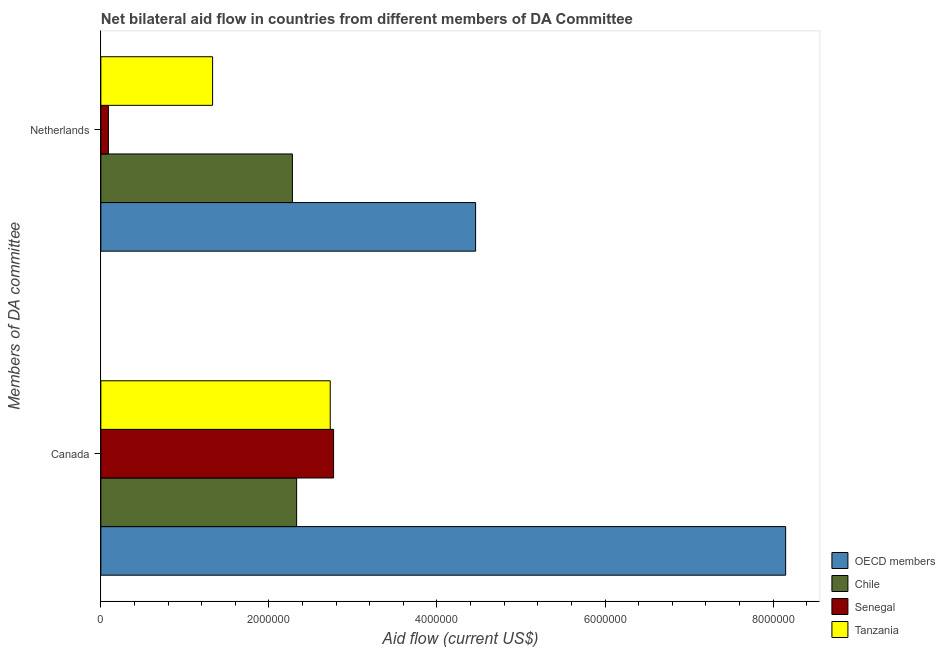How many different coloured bars are there?
Offer a very short reply. 4. How many groups of bars are there?
Offer a very short reply. 2. Are the number of bars on each tick of the Y-axis equal?
Provide a short and direct response. Yes. What is the amount of aid given by canada in OECD members?
Provide a short and direct response. 8.15e+06. Across all countries, what is the maximum amount of aid given by netherlands?
Keep it short and to the point. 4.46e+06. Across all countries, what is the minimum amount of aid given by netherlands?
Offer a terse response. 9.00e+04. In which country was the amount of aid given by canada minimum?
Give a very brief answer. Chile. What is the total amount of aid given by canada in the graph?
Give a very brief answer. 1.60e+07. What is the difference between the amount of aid given by canada in OECD members and that in Chile?
Ensure brevity in your answer.  5.82e+06. What is the difference between the amount of aid given by canada in Tanzania and the amount of aid given by netherlands in Chile?
Your answer should be compact. 4.50e+05. What is the average amount of aid given by canada per country?
Provide a short and direct response. 4.00e+06. What is the difference between the amount of aid given by netherlands and amount of aid given by canada in Senegal?
Provide a succinct answer. -2.68e+06. What is the ratio of the amount of aid given by netherlands in Tanzania to that in Senegal?
Make the answer very short. 14.78. What does the 2nd bar from the top in Canada represents?
Provide a short and direct response. Senegal. What does the 4th bar from the bottom in Canada represents?
Provide a short and direct response. Tanzania. How many bars are there?
Offer a very short reply. 8. What is the title of the graph?
Your response must be concise. Net bilateral aid flow in countries from different members of DA Committee. What is the label or title of the Y-axis?
Offer a terse response. Members of DA committee. What is the Aid flow (current US$) of OECD members in Canada?
Give a very brief answer. 8.15e+06. What is the Aid flow (current US$) of Chile in Canada?
Keep it short and to the point. 2.33e+06. What is the Aid flow (current US$) in Senegal in Canada?
Your answer should be compact. 2.77e+06. What is the Aid flow (current US$) of Tanzania in Canada?
Offer a terse response. 2.73e+06. What is the Aid flow (current US$) in OECD members in Netherlands?
Make the answer very short. 4.46e+06. What is the Aid flow (current US$) of Chile in Netherlands?
Your answer should be very brief. 2.28e+06. What is the Aid flow (current US$) of Senegal in Netherlands?
Offer a terse response. 9.00e+04. What is the Aid flow (current US$) of Tanzania in Netherlands?
Offer a terse response. 1.33e+06. Across all Members of DA committee, what is the maximum Aid flow (current US$) in OECD members?
Provide a succinct answer. 8.15e+06. Across all Members of DA committee, what is the maximum Aid flow (current US$) in Chile?
Your answer should be compact. 2.33e+06. Across all Members of DA committee, what is the maximum Aid flow (current US$) in Senegal?
Your answer should be compact. 2.77e+06. Across all Members of DA committee, what is the maximum Aid flow (current US$) of Tanzania?
Your response must be concise. 2.73e+06. Across all Members of DA committee, what is the minimum Aid flow (current US$) in OECD members?
Provide a short and direct response. 4.46e+06. Across all Members of DA committee, what is the minimum Aid flow (current US$) in Chile?
Your response must be concise. 2.28e+06. Across all Members of DA committee, what is the minimum Aid flow (current US$) of Senegal?
Your answer should be compact. 9.00e+04. Across all Members of DA committee, what is the minimum Aid flow (current US$) of Tanzania?
Your answer should be very brief. 1.33e+06. What is the total Aid flow (current US$) in OECD members in the graph?
Your answer should be very brief. 1.26e+07. What is the total Aid flow (current US$) in Chile in the graph?
Provide a short and direct response. 4.61e+06. What is the total Aid flow (current US$) in Senegal in the graph?
Provide a succinct answer. 2.86e+06. What is the total Aid flow (current US$) of Tanzania in the graph?
Make the answer very short. 4.06e+06. What is the difference between the Aid flow (current US$) of OECD members in Canada and that in Netherlands?
Keep it short and to the point. 3.69e+06. What is the difference between the Aid flow (current US$) of Senegal in Canada and that in Netherlands?
Provide a succinct answer. 2.68e+06. What is the difference between the Aid flow (current US$) of Tanzania in Canada and that in Netherlands?
Provide a short and direct response. 1.40e+06. What is the difference between the Aid flow (current US$) in OECD members in Canada and the Aid flow (current US$) in Chile in Netherlands?
Provide a succinct answer. 5.87e+06. What is the difference between the Aid flow (current US$) of OECD members in Canada and the Aid flow (current US$) of Senegal in Netherlands?
Your answer should be very brief. 8.06e+06. What is the difference between the Aid flow (current US$) of OECD members in Canada and the Aid flow (current US$) of Tanzania in Netherlands?
Offer a terse response. 6.82e+06. What is the difference between the Aid flow (current US$) in Chile in Canada and the Aid flow (current US$) in Senegal in Netherlands?
Provide a short and direct response. 2.24e+06. What is the difference between the Aid flow (current US$) of Chile in Canada and the Aid flow (current US$) of Tanzania in Netherlands?
Provide a short and direct response. 1.00e+06. What is the difference between the Aid flow (current US$) in Senegal in Canada and the Aid flow (current US$) in Tanzania in Netherlands?
Your answer should be compact. 1.44e+06. What is the average Aid flow (current US$) in OECD members per Members of DA committee?
Keep it short and to the point. 6.30e+06. What is the average Aid flow (current US$) of Chile per Members of DA committee?
Your response must be concise. 2.30e+06. What is the average Aid flow (current US$) in Senegal per Members of DA committee?
Give a very brief answer. 1.43e+06. What is the average Aid flow (current US$) of Tanzania per Members of DA committee?
Your response must be concise. 2.03e+06. What is the difference between the Aid flow (current US$) of OECD members and Aid flow (current US$) of Chile in Canada?
Make the answer very short. 5.82e+06. What is the difference between the Aid flow (current US$) of OECD members and Aid flow (current US$) of Senegal in Canada?
Make the answer very short. 5.38e+06. What is the difference between the Aid flow (current US$) in OECD members and Aid flow (current US$) in Tanzania in Canada?
Your response must be concise. 5.42e+06. What is the difference between the Aid flow (current US$) of Chile and Aid flow (current US$) of Senegal in Canada?
Keep it short and to the point. -4.40e+05. What is the difference between the Aid flow (current US$) in Chile and Aid flow (current US$) in Tanzania in Canada?
Make the answer very short. -4.00e+05. What is the difference between the Aid flow (current US$) of OECD members and Aid flow (current US$) of Chile in Netherlands?
Offer a very short reply. 2.18e+06. What is the difference between the Aid flow (current US$) of OECD members and Aid flow (current US$) of Senegal in Netherlands?
Ensure brevity in your answer.  4.37e+06. What is the difference between the Aid flow (current US$) of OECD members and Aid flow (current US$) of Tanzania in Netherlands?
Provide a short and direct response. 3.13e+06. What is the difference between the Aid flow (current US$) in Chile and Aid flow (current US$) in Senegal in Netherlands?
Provide a succinct answer. 2.19e+06. What is the difference between the Aid flow (current US$) in Chile and Aid flow (current US$) in Tanzania in Netherlands?
Offer a terse response. 9.50e+05. What is the difference between the Aid flow (current US$) of Senegal and Aid flow (current US$) of Tanzania in Netherlands?
Offer a terse response. -1.24e+06. What is the ratio of the Aid flow (current US$) in OECD members in Canada to that in Netherlands?
Provide a short and direct response. 1.83. What is the ratio of the Aid flow (current US$) of Chile in Canada to that in Netherlands?
Offer a terse response. 1.02. What is the ratio of the Aid flow (current US$) in Senegal in Canada to that in Netherlands?
Provide a succinct answer. 30.78. What is the ratio of the Aid flow (current US$) in Tanzania in Canada to that in Netherlands?
Your answer should be very brief. 2.05. What is the difference between the highest and the second highest Aid flow (current US$) of OECD members?
Your answer should be compact. 3.69e+06. What is the difference between the highest and the second highest Aid flow (current US$) of Chile?
Give a very brief answer. 5.00e+04. What is the difference between the highest and the second highest Aid flow (current US$) of Senegal?
Offer a very short reply. 2.68e+06. What is the difference between the highest and the second highest Aid flow (current US$) of Tanzania?
Keep it short and to the point. 1.40e+06. What is the difference between the highest and the lowest Aid flow (current US$) in OECD members?
Keep it short and to the point. 3.69e+06. What is the difference between the highest and the lowest Aid flow (current US$) in Chile?
Provide a succinct answer. 5.00e+04. What is the difference between the highest and the lowest Aid flow (current US$) in Senegal?
Your response must be concise. 2.68e+06. What is the difference between the highest and the lowest Aid flow (current US$) in Tanzania?
Your response must be concise. 1.40e+06. 